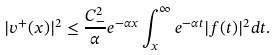<formula> <loc_0><loc_0><loc_500><loc_500>| v ^ { + } ( x ) | ^ { 2 } \leq \frac { C ^ { 2 } _ { - } } { \alpha } e ^ { - \alpha x } \int _ { x } ^ { \infty } e ^ { - \alpha t } | f ( t ) | ^ { 2 } d t .</formula> 